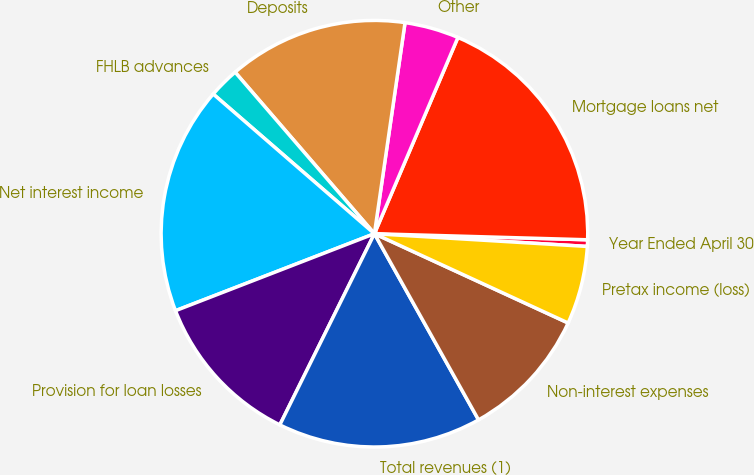<chart> <loc_0><loc_0><loc_500><loc_500><pie_chart><fcel>Year Ended April 30<fcel>Mortgage loans net<fcel>Other<fcel>Deposits<fcel>FHLB advances<fcel>Net interest income<fcel>Provision for loan losses<fcel>Total revenues (1)<fcel>Non-interest expenses<fcel>Pretax income (loss)<nl><fcel>0.5%<fcel>19.05%<fcel>4.11%<fcel>13.62%<fcel>2.31%<fcel>17.24%<fcel>11.81%<fcel>15.43%<fcel>10.01%<fcel>5.92%<nl></chart> 